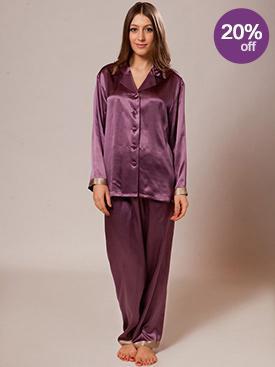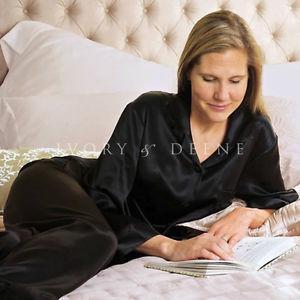The first image is the image on the left, the second image is the image on the right. Examine the images to the left and right. Is the description "In one image, a woman is wearing purple pajamas" accurate? Answer yes or no. Yes. 